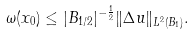<formula> <loc_0><loc_0><loc_500><loc_500>\omega ( x _ { 0 } ) \leq | B _ { 1 / 2 } | ^ { - \frac { 1 } { 2 } } \| \Delta u \| _ { L ^ { 2 } ( B _ { 1 } ) } .</formula> 